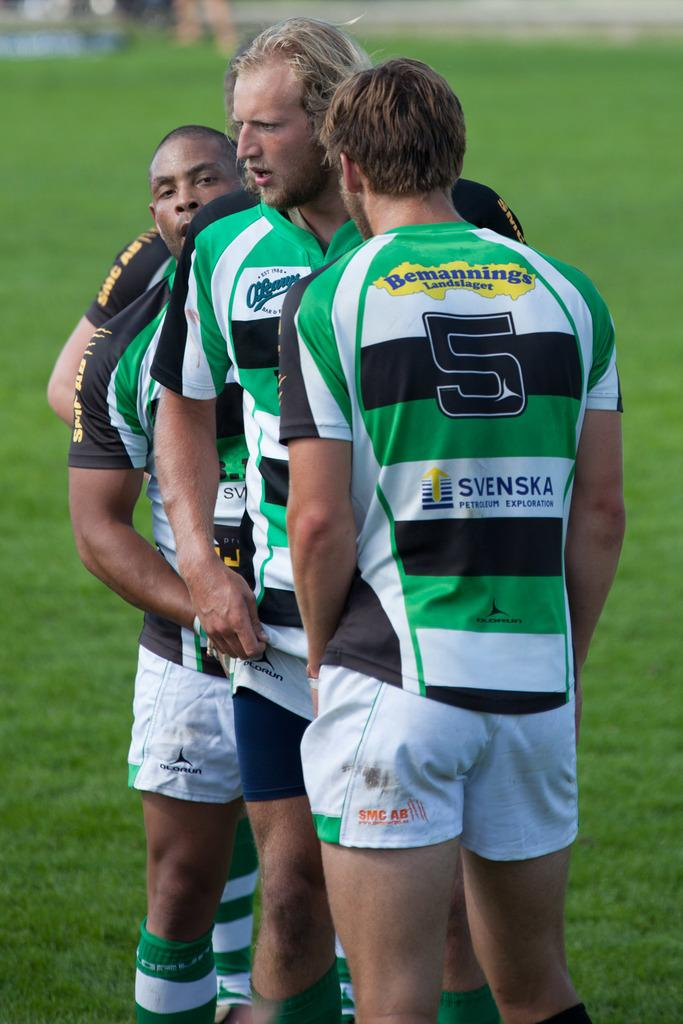<image>
Provide a brief description of the given image. Four players stand close to each other and the back of their shirts reads " Svenka  petroleum exploration". 